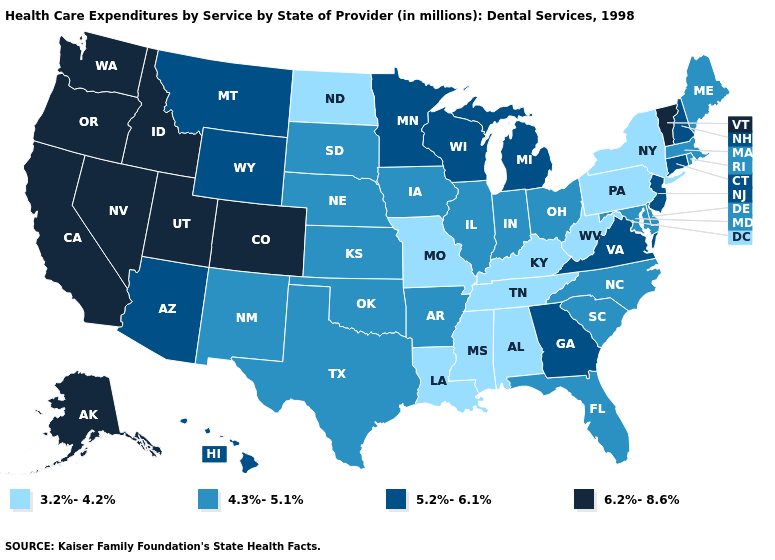Does West Virginia have the lowest value in the USA?
Be succinct. Yes. Does North Dakota have the same value as Kentucky?
Be succinct. Yes. What is the value of Oklahoma?
Give a very brief answer. 4.3%-5.1%. Which states have the lowest value in the Northeast?
Short answer required. New York, Pennsylvania. Does West Virginia have the lowest value in the South?
Concise answer only. Yes. Which states have the highest value in the USA?
Short answer required. Alaska, California, Colorado, Idaho, Nevada, Oregon, Utah, Vermont, Washington. Name the states that have a value in the range 4.3%-5.1%?
Give a very brief answer. Arkansas, Delaware, Florida, Illinois, Indiana, Iowa, Kansas, Maine, Maryland, Massachusetts, Nebraska, New Mexico, North Carolina, Ohio, Oklahoma, Rhode Island, South Carolina, South Dakota, Texas. What is the value of Minnesota?
Be succinct. 5.2%-6.1%. Does Mississippi have the highest value in the USA?
Keep it brief. No. Does the first symbol in the legend represent the smallest category?
Answer briefly. Yes. Name the states that have a value in the range 6.2%-8.6%?
Answer briefly. Alaska, California, Colorado, Idaho, Nevada, Oregon, Utah, Vermont, Washington. Name the states that have a value in the range 4.3%-5.1%?
Write a very short answer. Arkansas, Delaware, Florida, Illinois, Indiana, Iowa, Kansas, Maine, Maryland, Massachusetts, Nebraska, New Mexico, North Carolina, Ohio, Oklahoma, Rhode Island, South Carolina, South Dakota, Texas. Name the states that have a value in the range 4.3%-5.1%?
Write a very short answer. Arkansas, Delaware, Florida, Illinois, Indiana, Iowa, Kansas, Maine, Maryland, Massachusetts, Nebraska, New Mexico, North Carolina, Ohio, Oklahoma, Rhode Island, South Carolina, South Dakota, Texas. Does Maine have the same value as New York?
Keep it brief. No. What is the highest value in states that border Kansas?
Short answer required. 6.2%-8.6%. 